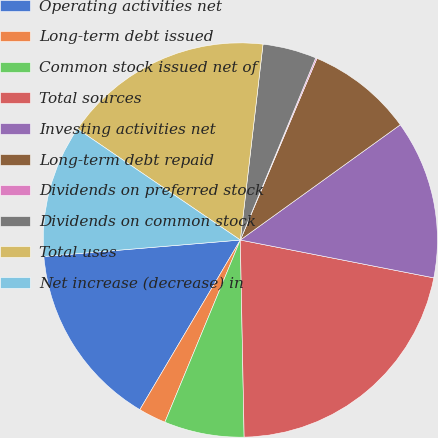Convert chart to OTSL. <chart><loc_0><loc_0><loc_500><loc_500><pie_chart><fcel>Operating activities net<fcel>Long-term debt issued<fcel>Common stock issued net of<fcel>Total sources<fcel>Investing activities net<fcel>Long-term debt repaid<fcel>Dividends on preferred stock<fcel>Dividends on common stock<fcel>Total uses<fcel>Net increase (decrease) in<nl><fcel>15.16%<fcel>2.26%<fcel>6.56%<fcel>21.62%<fcel>13.01%<fcel>8.71%<fcel>0.11%<fcel>4.41%<fcel>17.31%<fcel>10.86%<nl></chart> 